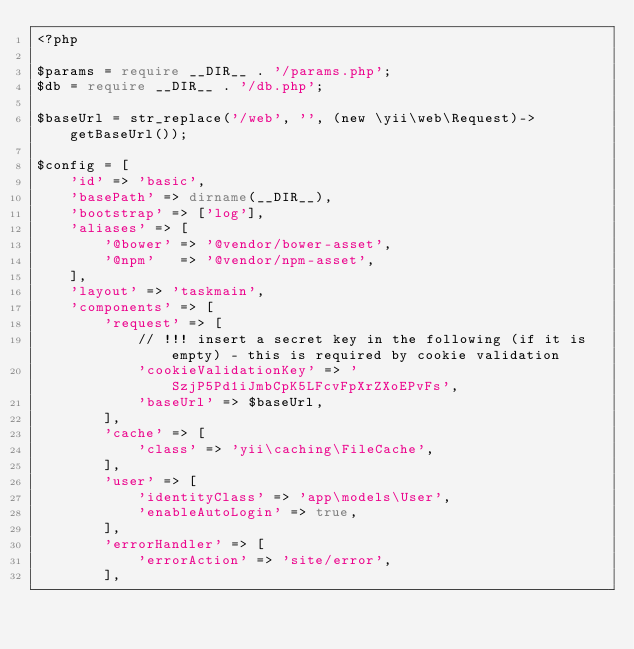Convert code to text. <code><loc_0><loc_0><loc_500><loc_500><_PHP_><?php

$params = require __DIR__ . '/params.php';
$db = require __DIR__ . '/db.php';

$baseUrl = str_replace('/web', '', (new \yii\web\Request)->getBaseUrl());

$config = [
    'id' => 'basic',
    'basePath' => dirname(__DIR__),
    'bootstrap' => ['log'],
    'aliases' => [
        '@bower' => '@vendor/bower-asset',
        '@npm'   => '@vendor/npm-asset',
    ],
    'layout' => 'taskmain',
    'components' => [
        'request' => [
            // !!! insert a secret key in the following (if it is empty) - this is required by cookie validation
            'cookieValidationKey' => 'SzjP5Pd1iJmbCpK5LFcvFpXrZXoEPvFs',
            'baseUrl' => $baseUrl,
        ],
        'cache' => [
            'class' => 'yii\caching\FileCache',
        ],
        'user' => [
            'identityClass' => 'app\models\User',
            'enableAutoLogin' => true,
        ],
        'errorHandler' => [
            'errorAction' => 'site/error',
        ],</code> 